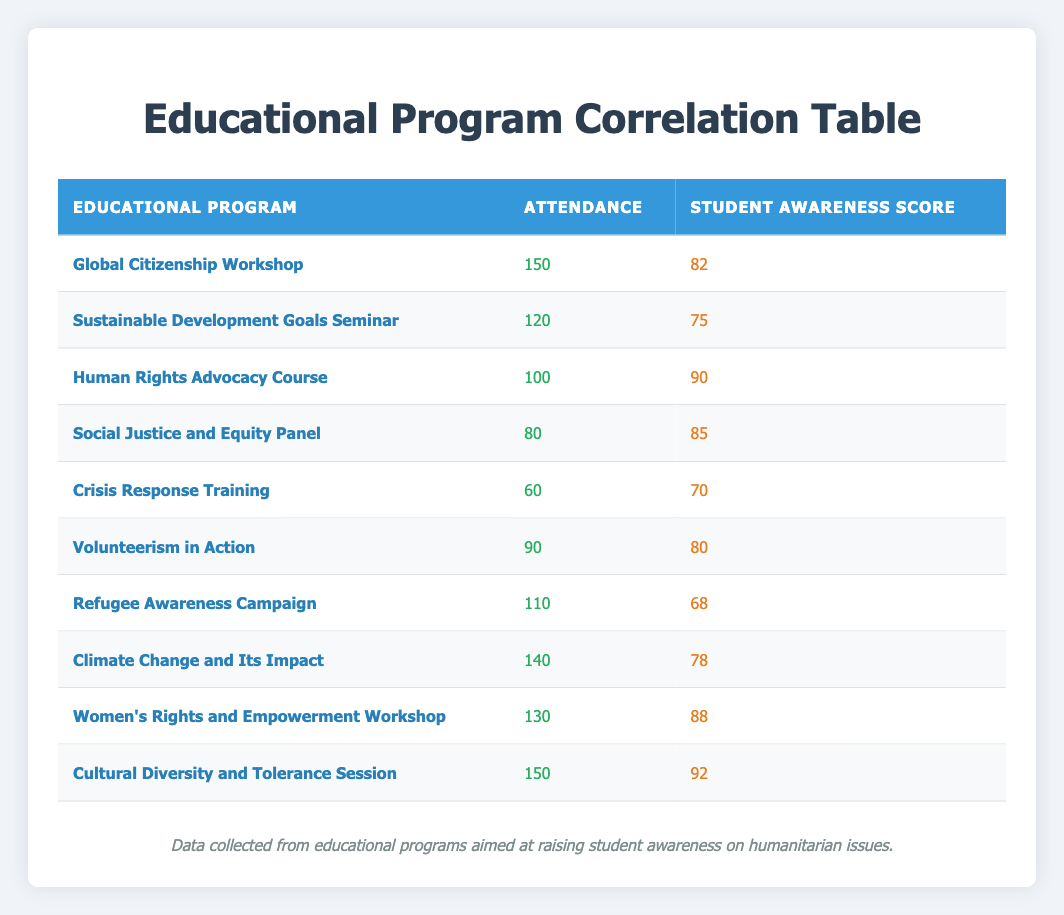What is the highest student awareness score in the table? By examining the "Student Awareness Score" column, I find that the highest score is 92 associated with the "Cultural Diversity and Tolerance Session."
Answer: 92 Which educational program had the lowest attendance? Looking through the "Attendance" column, "Crisis Response Training" has the lowest attendance with a value of 60.
Answer: 60 What is the average student awareness score for programs with an attendance of 100 or more? The eligible programs are "Global Citizenship Workshop" (82), "Sustainable Development Goals Seminar" (75), "Human Rights Advocacy Course" (90), "Volunteerism in Action" (80), "Refugee Awareness Campaign" (68), "Climate Change and Its Impact" (78), "Women's Rights and Empowerment Workshop" (88), and "Cultural Diversity and Tolerance Session" (92). Their total combined score is 82 + 75 + 90 + 80 + 68 + 78 + 88 + 92 = 675. Since there are 8 programs, the average score is 675/8 = 84.375.
Answer: 84.375 Do more students attend the "Global Citizenship Workshop" than the "Crisis Response Training"? The attendance for the "Global Citizenship Workshop" is 150, while for the "Crisis Response Training" it is 60. Since 150 is greater than 60, the answer is yes.
Answer: Yes How many programs had a student awareness score above 80? By reviewing the "Student Awareness Score," the programs with scores above 80 are "Global Citizenship Workshop" (82), "Human Rights Advocacy Course" (90), "Social Justice and Equity Panel" (85), "Volunteerism in Action" (80), "Women's Rights and Empowerment Workshop" (88), and "Cultural Diversity and Tolerance Session" (92). This totals to 5 programs.
Answer: 5 What is the difference in attendance between the program with the highest attendance and the program with the lowest attendance? The highest attendance is 150 for "Global Citizenship Workshop" and "Cultural Diversity and Tolerance Session." The lowest attendance is 60 for "Crisis Response Training." The difference is 150 - 60 = 90.
Answer: 90 Which program had a student awareness score closest to the average score? First, we calculate the average of all scores: (82 + 75 + 90 + 85 + 70 + 80 + 68 + 78 + 88 + 92) / 10 = 80.8. The scores closest to this average are "Volunteerism in Action" (80) and "Crisis Response Training" (70), with scores of 80 and 70.
Answer: Volunteerism in Action 